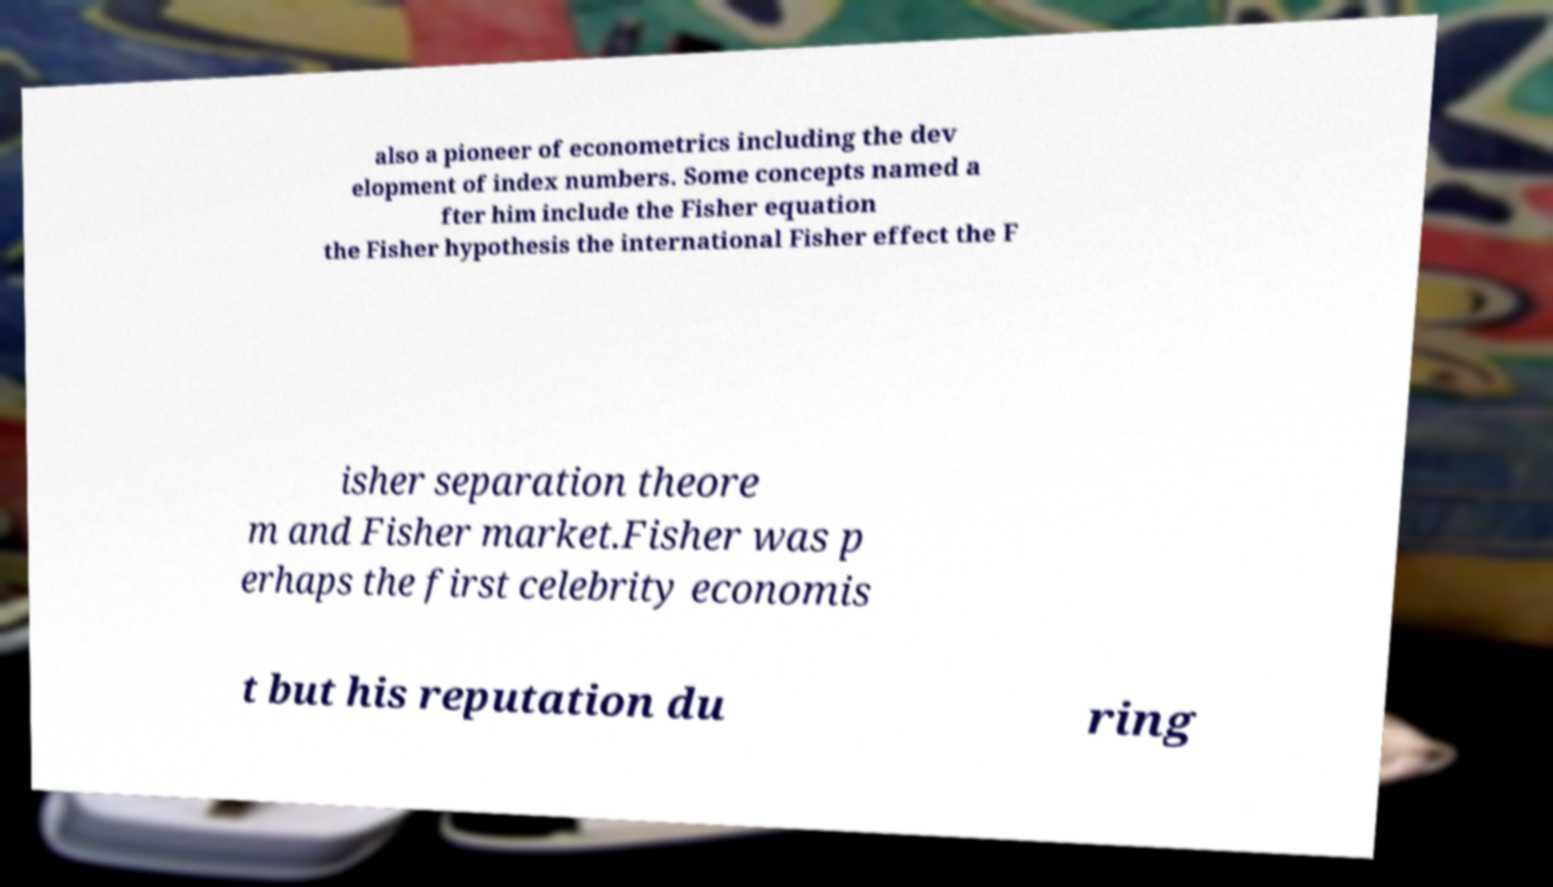Can you accurately transcribe the text from the provided image for me? also a pioneer of econometrics including the dev elopment of index numbers. Some concepts named a fter him include the Fisher equation the Fisher hypothesis the international Fisher effect the F isher separation theore m and Fisher market.Fisher was p erhaps the first celebrity economis t but his reputation du ring 